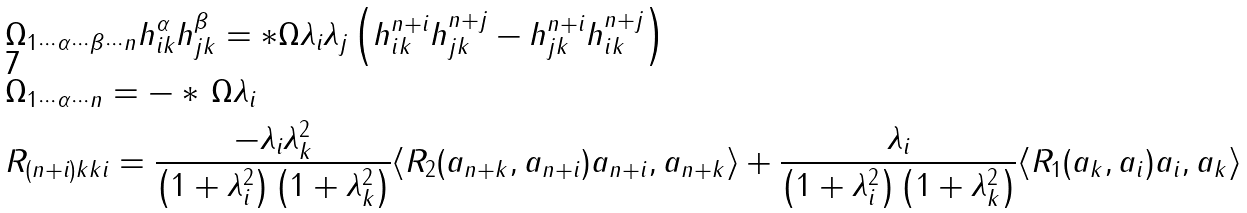Convert formula to latex. <formula><loc_0><loc_0><loc_500><loc_500>& \Omega _ { 1 \cdots \alpha \cdots \beta \cdots n } h _ { i k } ^ { \alpha } h _ { j k } ^ { \beta } = * \Omega \lambda _ { i } \lambda _ { j } \left ( h _ { i k } ^ { n + i } h _ { j k } ^ { n + j } - h _ { j k } ^ { n + i } h _ { i k } ^ { n + j } \right ) \\ & \Omega _ { 1 \cdots \alpha \cdots n } = - * \, \Omega \lambda _ { i } \\ & R _ { ( n + i ) k k i } = \frac { - \lambda _ { i } \lambda _ { k } ^ { 2 } } { \left ( 1 + \lambda _ { i } ^ { 2 } \right ) \left ( 1 + \lambda _ { k } ^ { 2 } \right ) } \langle R _ { 2 } ( a _ { n + k } , a _ { n + i } ) a _ { n + i } , a _ { n + k } \rangle + \frac { \lambda _ { i } } { \left ( 1 + \lambda _ { i } ^ { 2 } \right ) \left ( 1 + \lambda _ { k } ^ { 2 } \right ) } \langle R _ { 1 } ( a _ { k } , a _ { i } ) a _ { i } , a _ { k } \rangle</formula> 